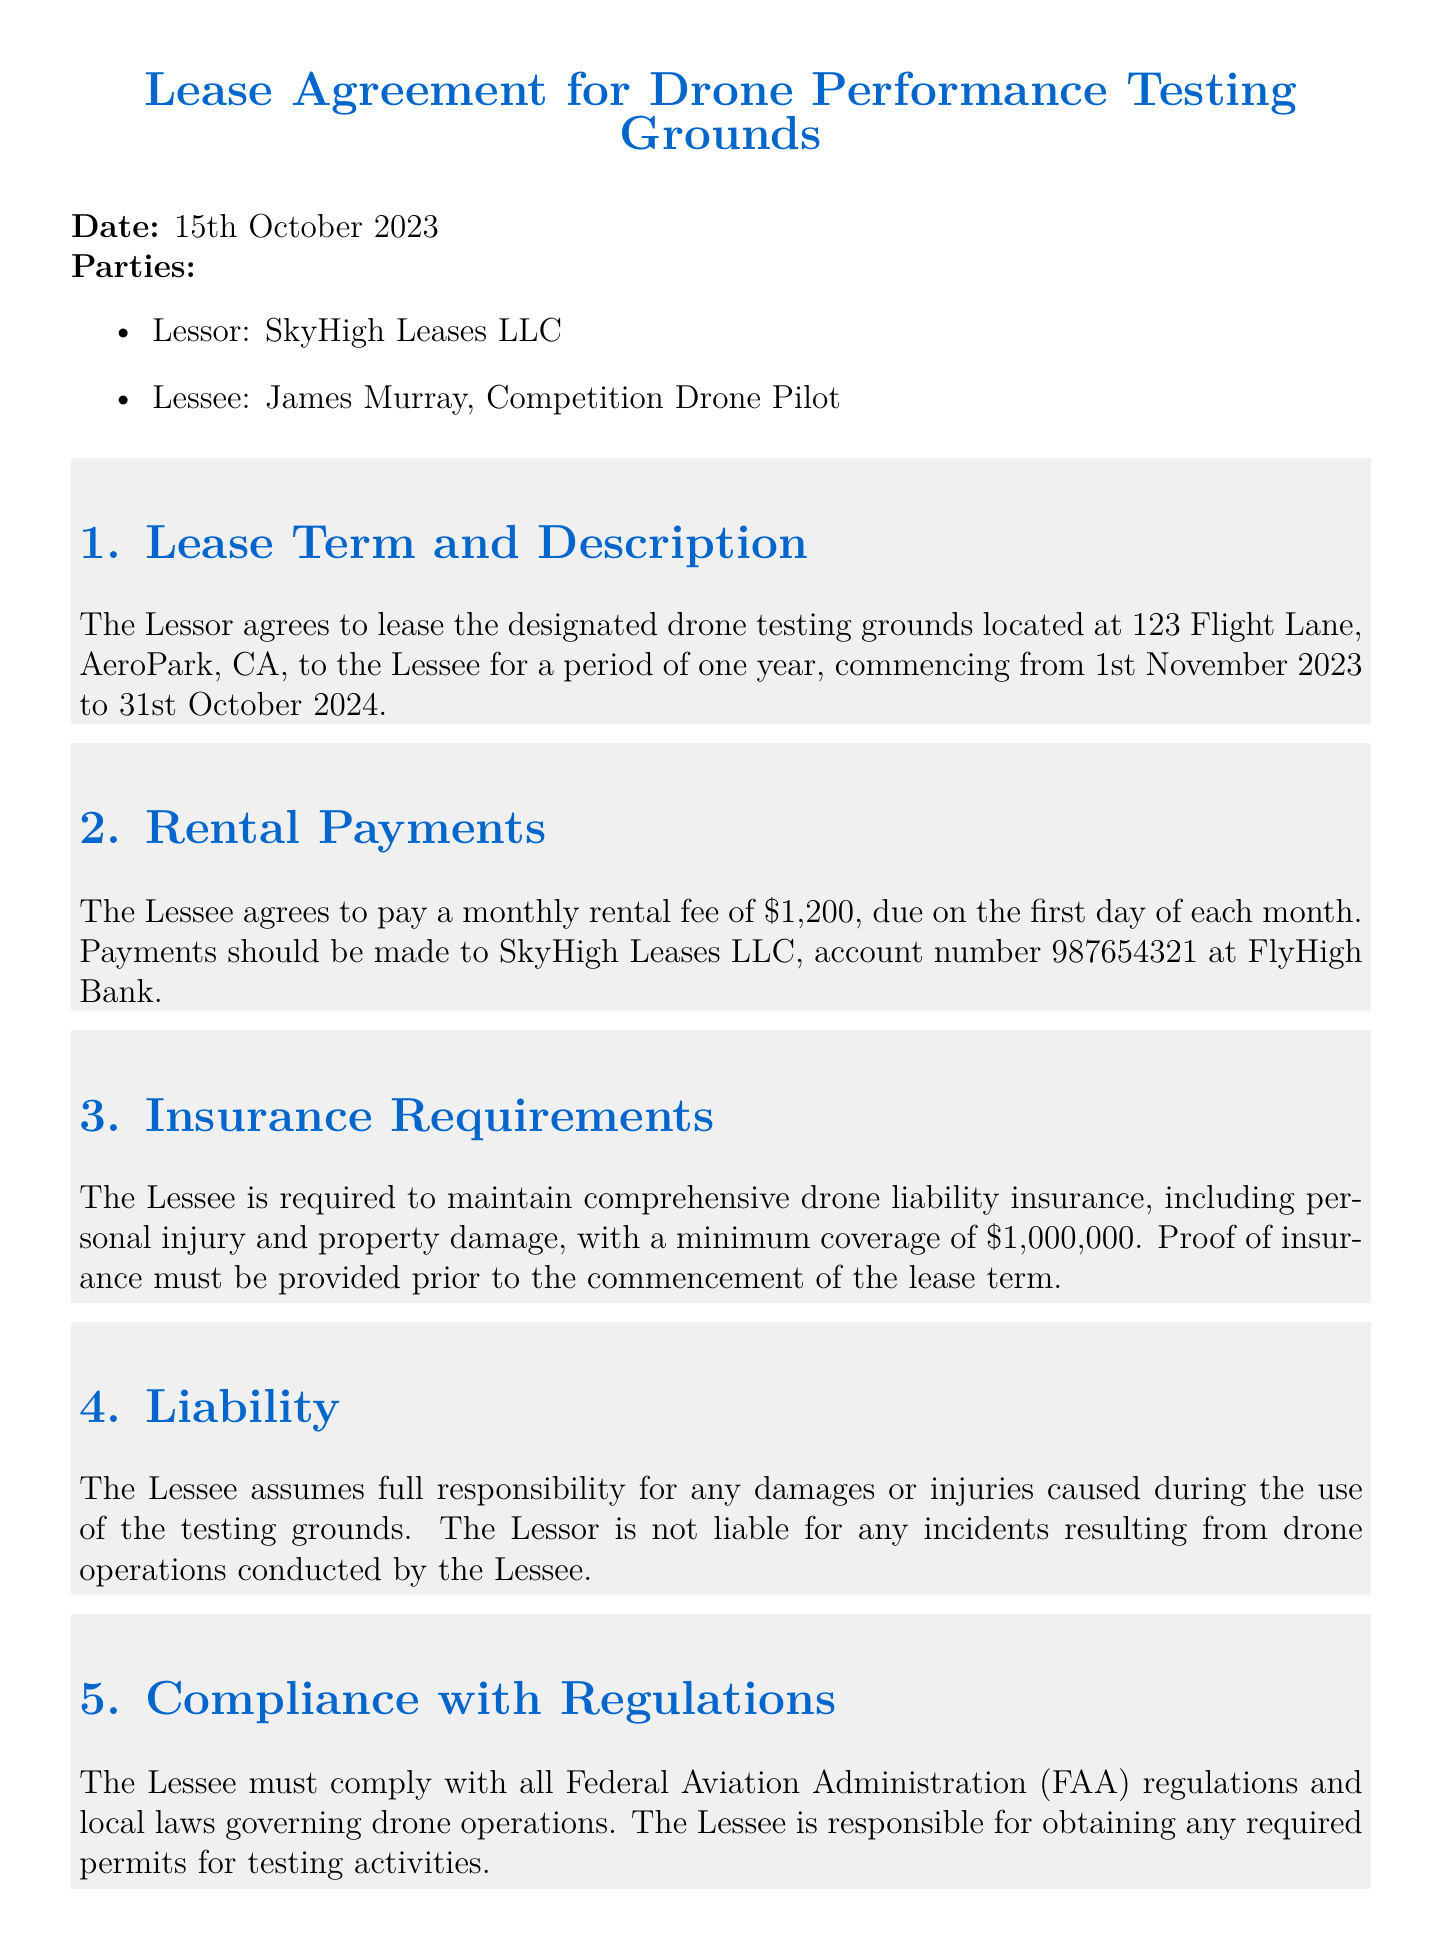What is the lease term duration? The lease term duration is specified in the document, which states it lasts for one year, from November 1st, 2023 to October 31st, 2024.
Answer: One year What is the monthly rental fee? The document mentions that the monthly rental fee to be paid by the Lessee is $1,200.
Answer: $1,200 What is the minimum required insurance coverage? According to the insurance requirements detailed in the document, the Lessee must maintain a minimum coverage of $1,000,000.
Answer: $1,000,000 Who is the lessor in the agreement? The lessor is identified at the beginning of the document as SkyHigh Leases LLC.
Answer: SkyHigh Leases LLC What responsibility does the Lessee assume? The document states that the Lessee assumes full responsibility for any damages or injuries caused during the use of the testing grounds.
Answer: Full responsibility for damages or injuries What federal regulations must the Lessee comply with? The Lessee is required to comply with all Federal Aviation Administration (FAA) regulations as mentioned in the document.
Answer: FAA regulations When must proof of insurance be provided? The document states that proof of insurance must be provided prior to the commencement of the lease term.
Answer: Prior to commencement What is the location of the leased testing grounds? The document specifies the location of the testing grounds as 123 Flight Lane, AeroPark, CA.
Answer: 123 Flight Lane, AeroPark, CA Who is the Lessee in the agreement? The Lessee is identified in the document as James Murray, a Competition Drone Pilot.
Answer: James Murray 